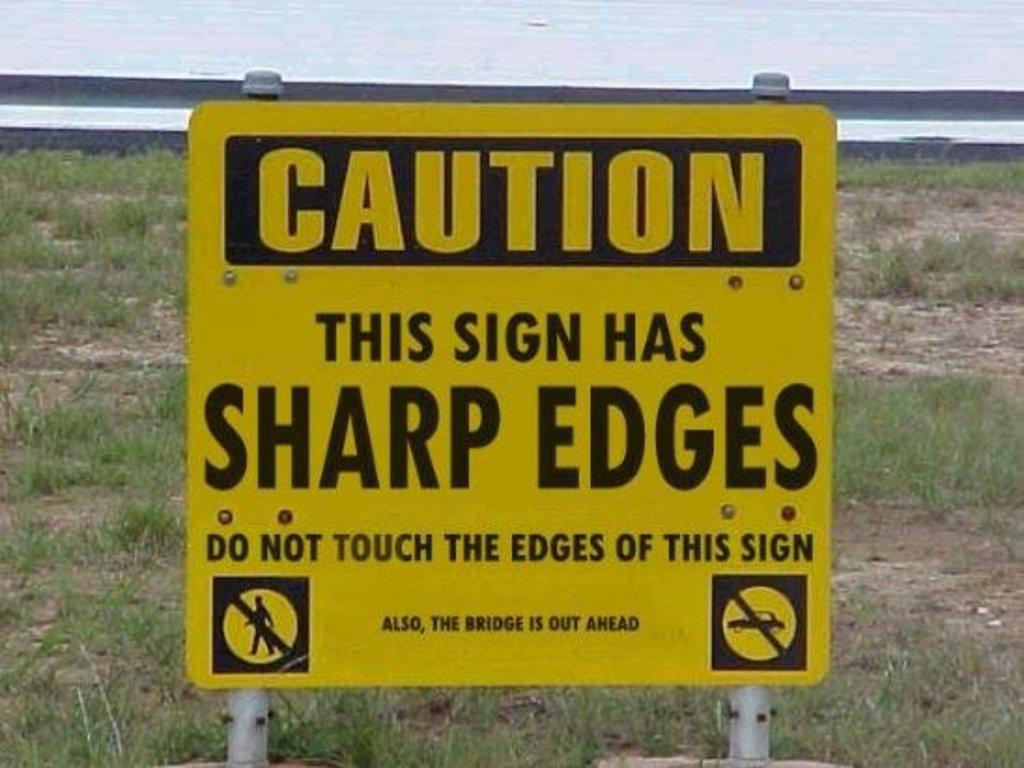Provide a one-sentence caption for the provided image. A yellow sign in front of an empty lot cautions that it's edges are sharp. 